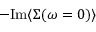Convert formula to latex. <formula><loc_0><loc_0><loc_500><loc_500>- I m \langle \Sigma ( \omega = 0 ) \rangle \,</formula> 